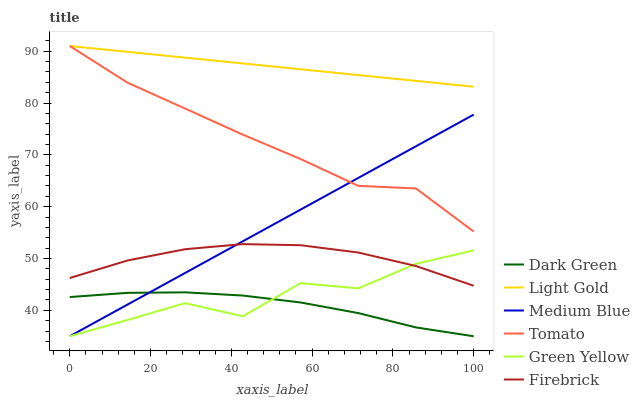Does Firebrick have the minimum area under the curve?
Answer yes or no. No. Does Firebrick have the maximum area under the curve?
Answer yes or no. No. Is Firebrick the smoothest?
Answer yes or no. No. Is Firebrick the roughest?
Answer yes or no. No. Does Firebrick have the lowest value?
Answer yes or no. No. Does Firebrick have the highest value?
Answer yes or no. No. Is Firebrick less than Tomato?
Answer yes or no. Yes. Is Tomato greater than Firebrick?
Answer yes or no. Yes. Does Firebrick intersect Tomato?
Answer yes or no. No. 